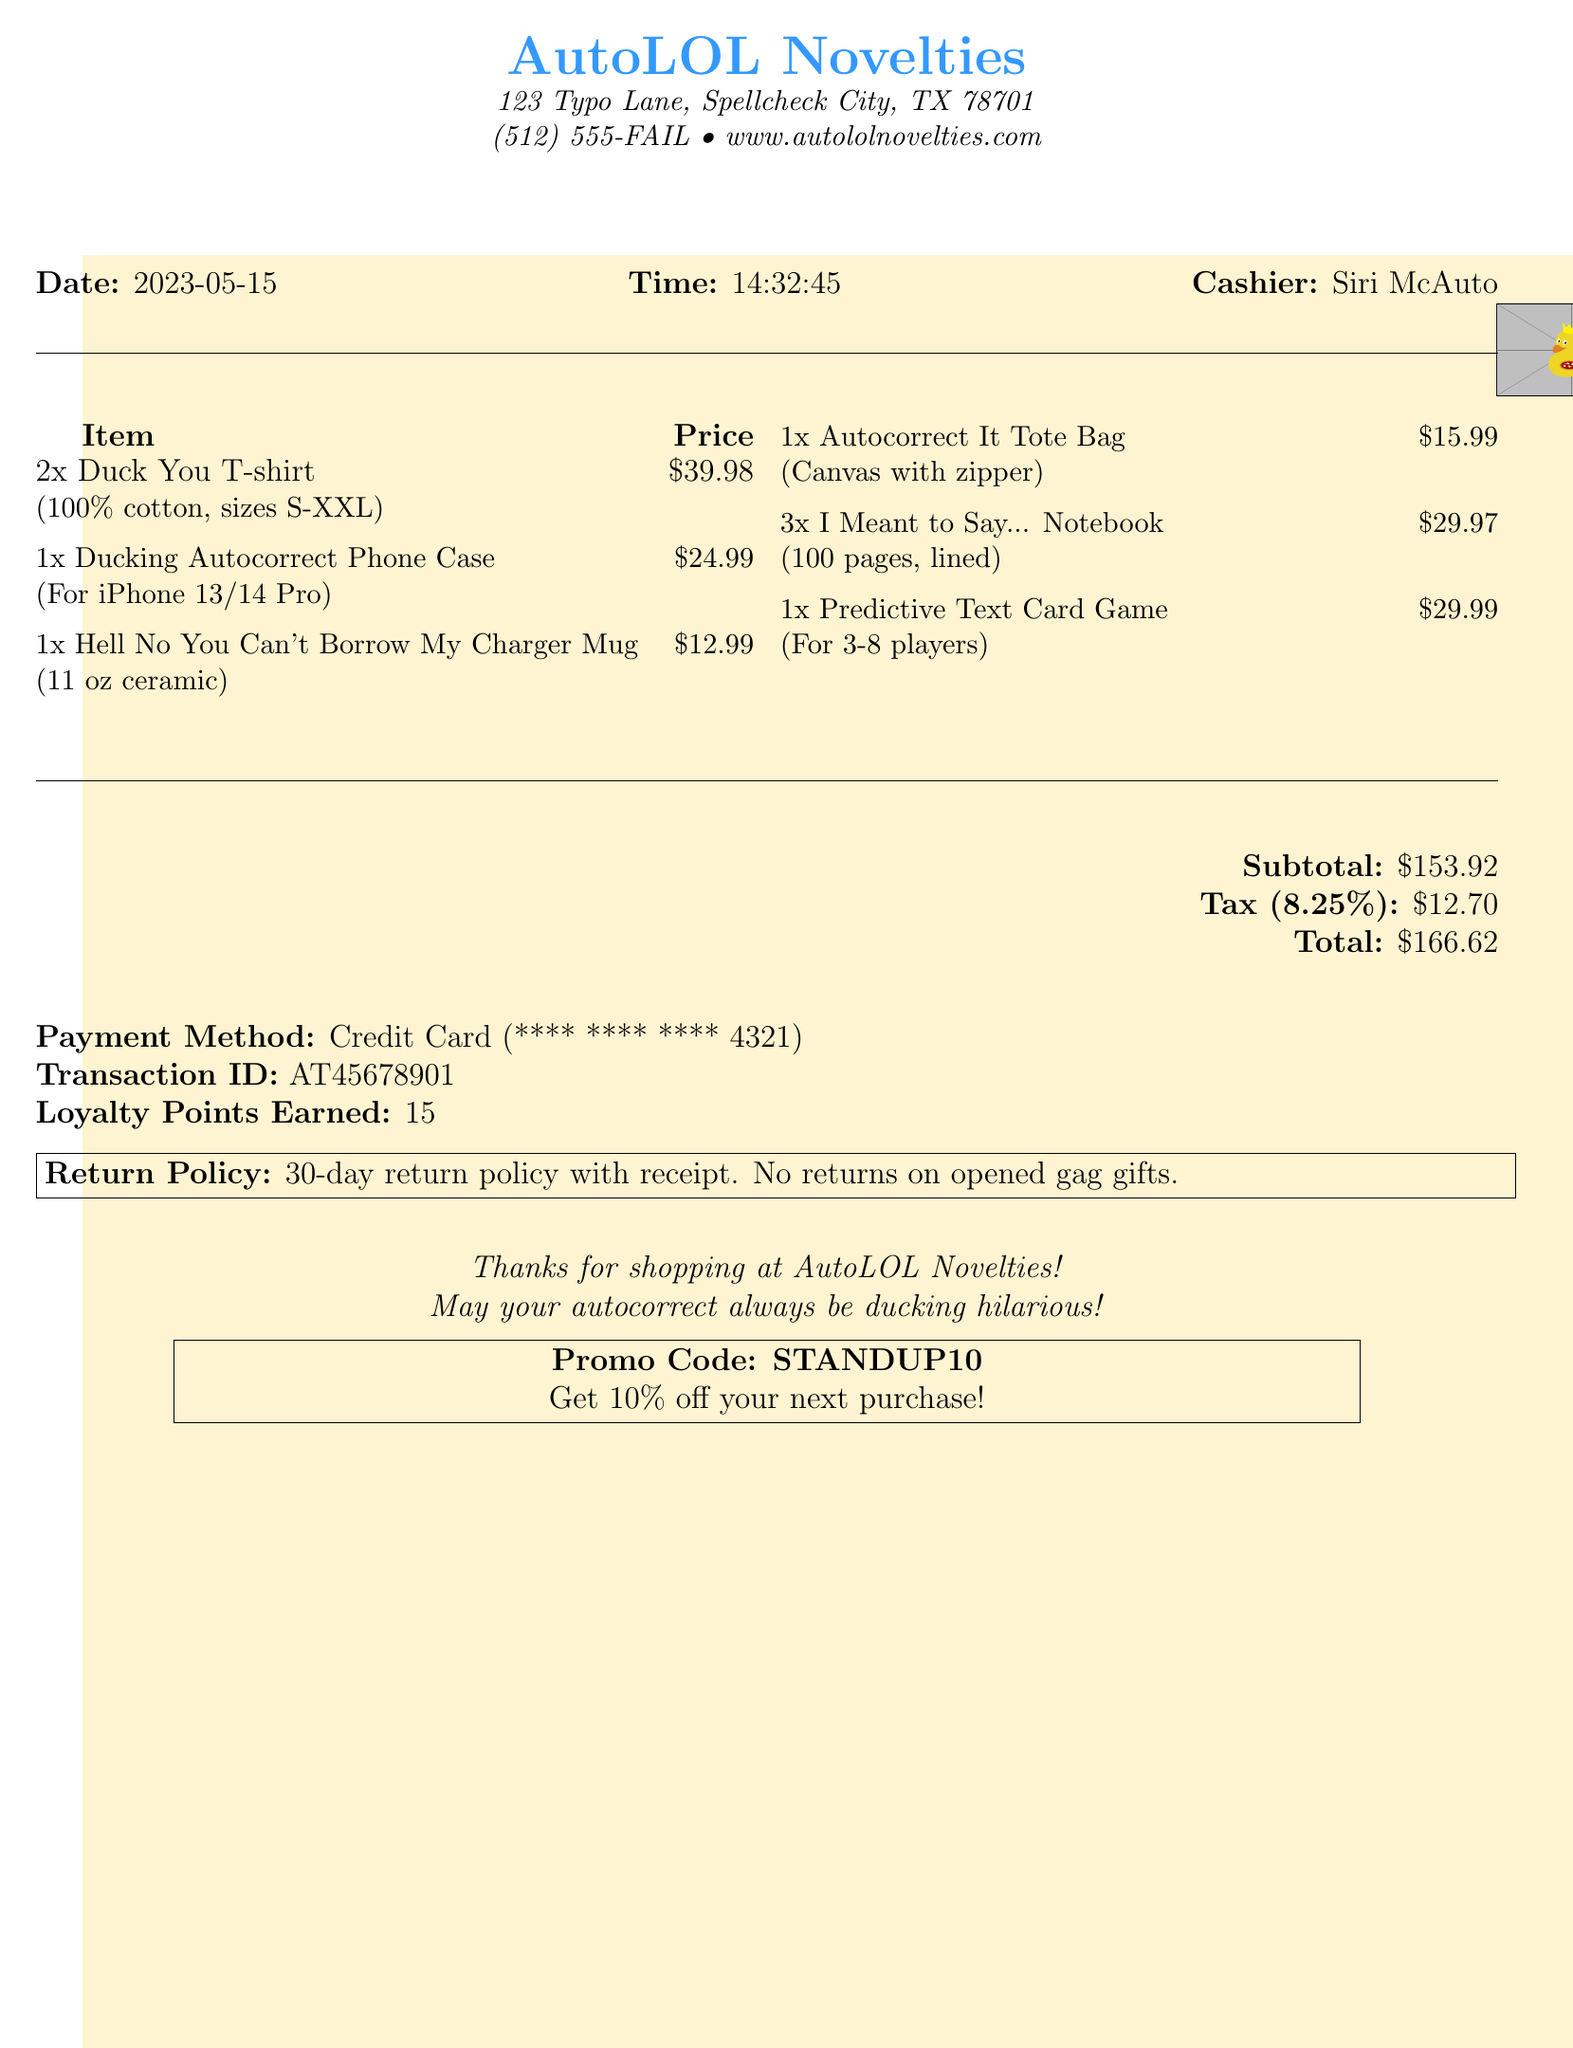what is the shop name? The shop name is mentioned at the top of the document.
Answer: AutoLOL Novelties what is the address of the shop? The address is listed under the shop name in the document.
Answer: 123 Typo Lane, Spellcheck City, TX 78701 who was the cashier? The cashier name is provided in the receipt details.
Answer: Siri McAuto how many Duck You T-shirts were purchased? The quantity purchased is indicated next to the item on the receipt.
Answer: 2 what is the tax amount? The tax amount is explicitly stated in the total calculation section of the document.
Answer: 12.70 what is the return policy for gag gifts? The return policy section outlines the specifics of returns for gag gifts.
Answer: No returns on opened gag gifts how much discount can be earned with the promo code? The promo code section details the discount available for the next purchase.
Answer: 10% off what is the total amount spent? The total amount appears in the total calculation section of the document.
Answer: 166.62 which item has the highest price? The prices of the items can be compared to identify the highest one.
Answer: Predictive Text Card Game 